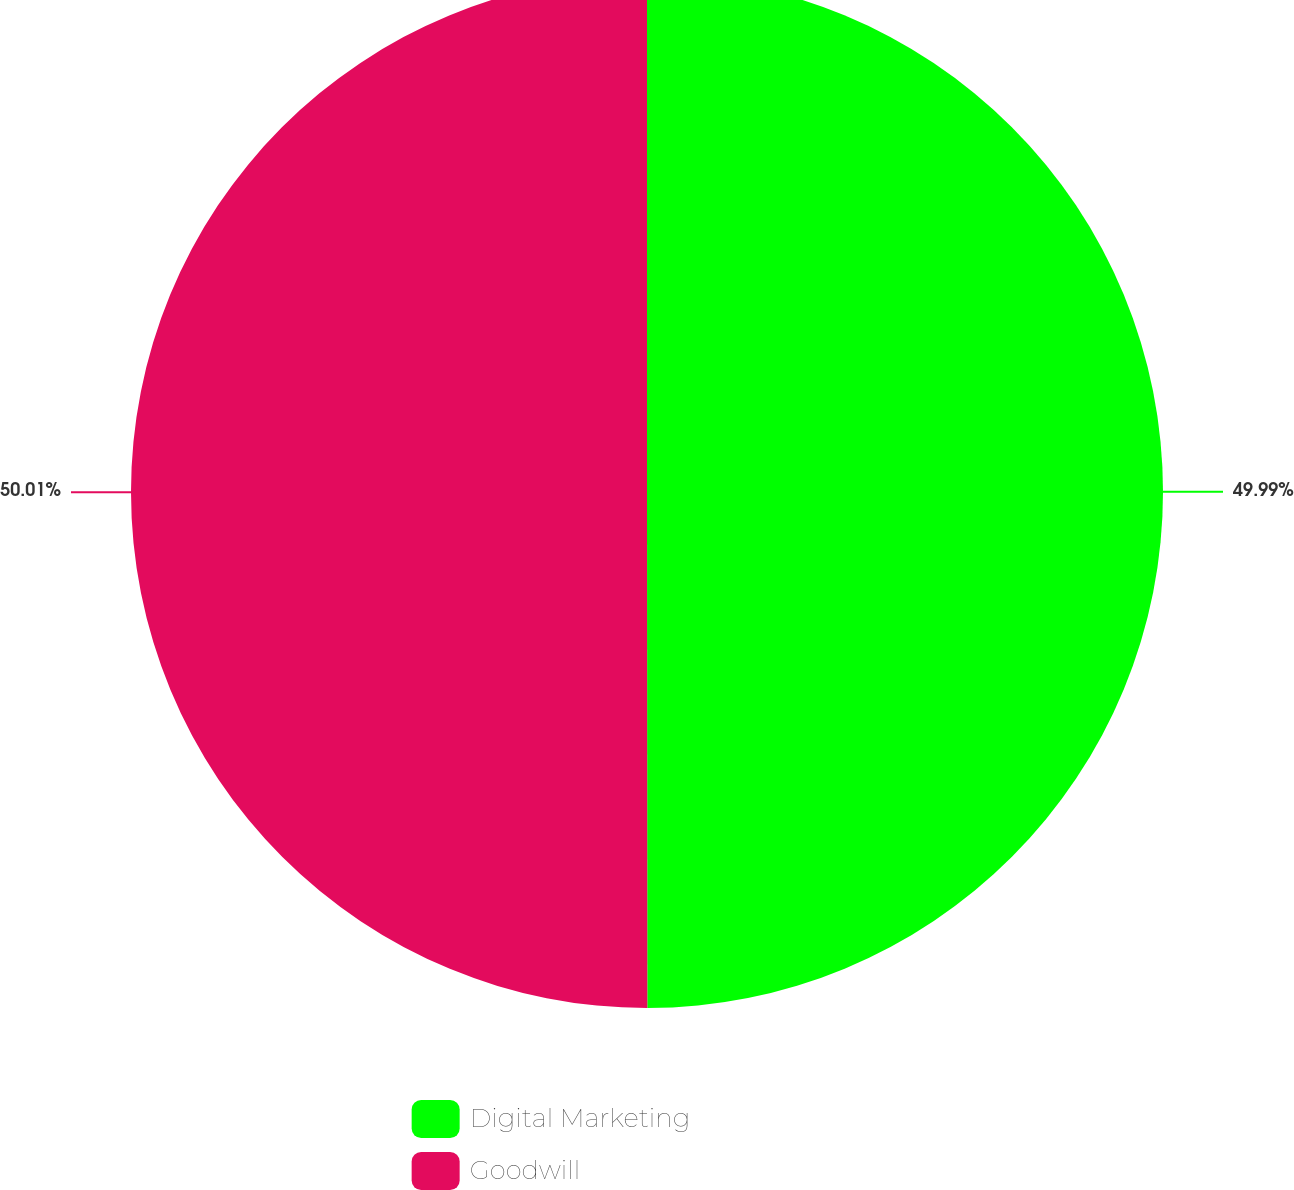Convert chart. <chart><loc_0><loc_0><loc_500><loc_500><pie_chart><fcel>Digital Marketing<fcel>Goodwill<nl><fcel>49.99%<fcel>50.01%<nl></chart> 